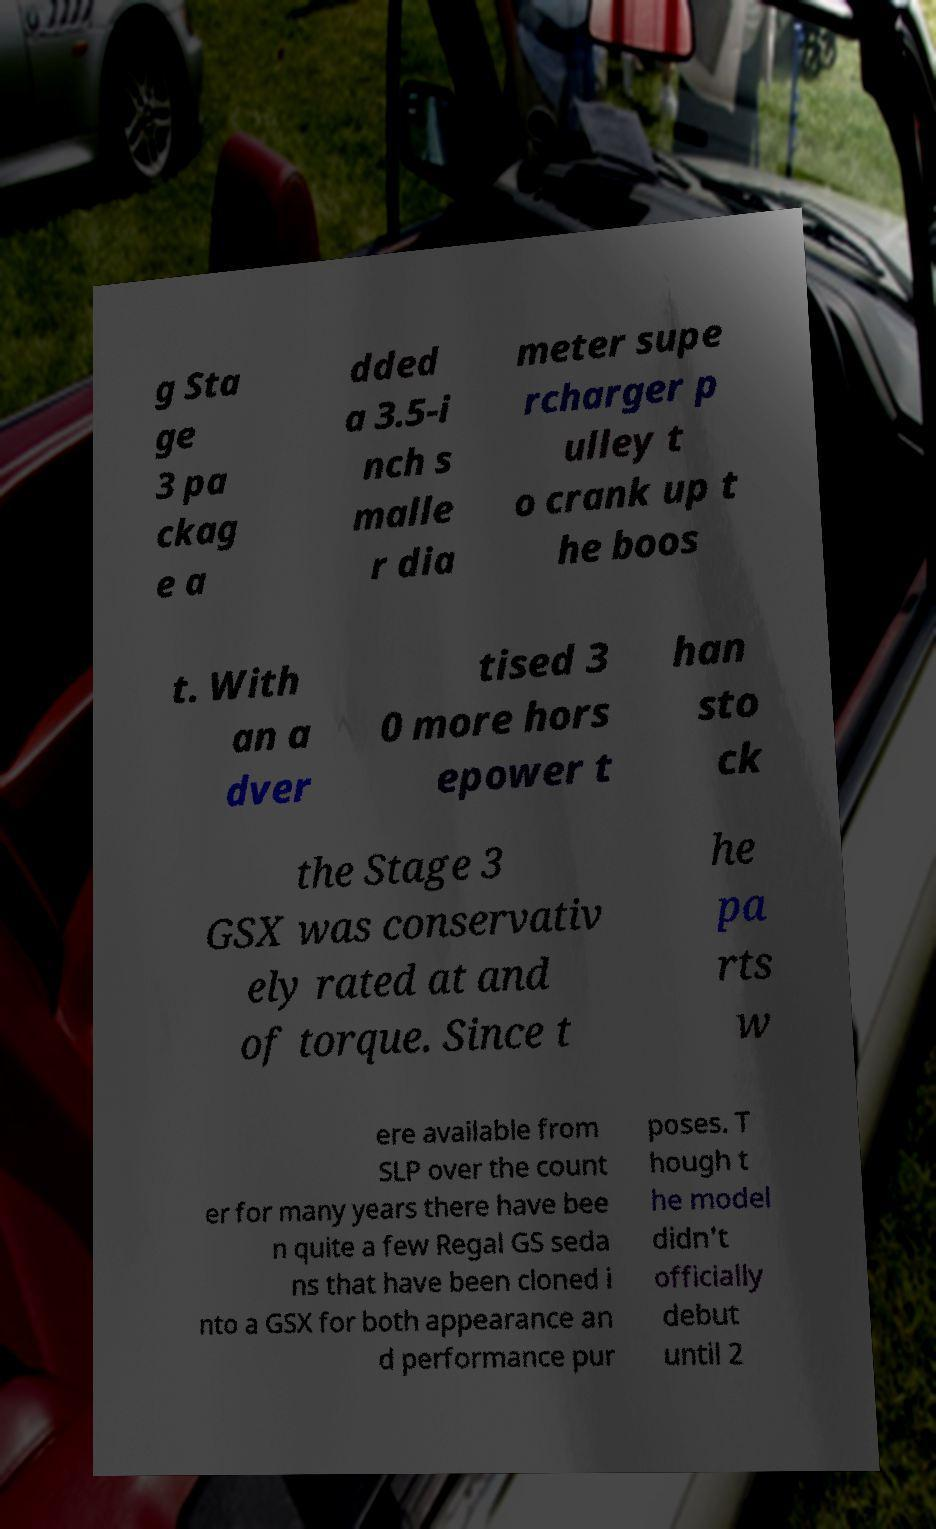Could you extract and type out the text from this image? g Sta ge 3 pa ckag e a dded a 3.5-i nch s malle r dia meter supe rcharger p ulley t o crank up t he boos t. With an a dver tised 3 0 more hors epower t han sto ck the Stage 3 GSX was conservativ ely rated at and of torque. Since t he pa rts w ere available from SLP over the count er for many years there have bee n quite a few Regal GS seda ns that have been cloned i nto a GSX for both appearance an d performance pur poses. T hough t he model didn't officially debut until 2 